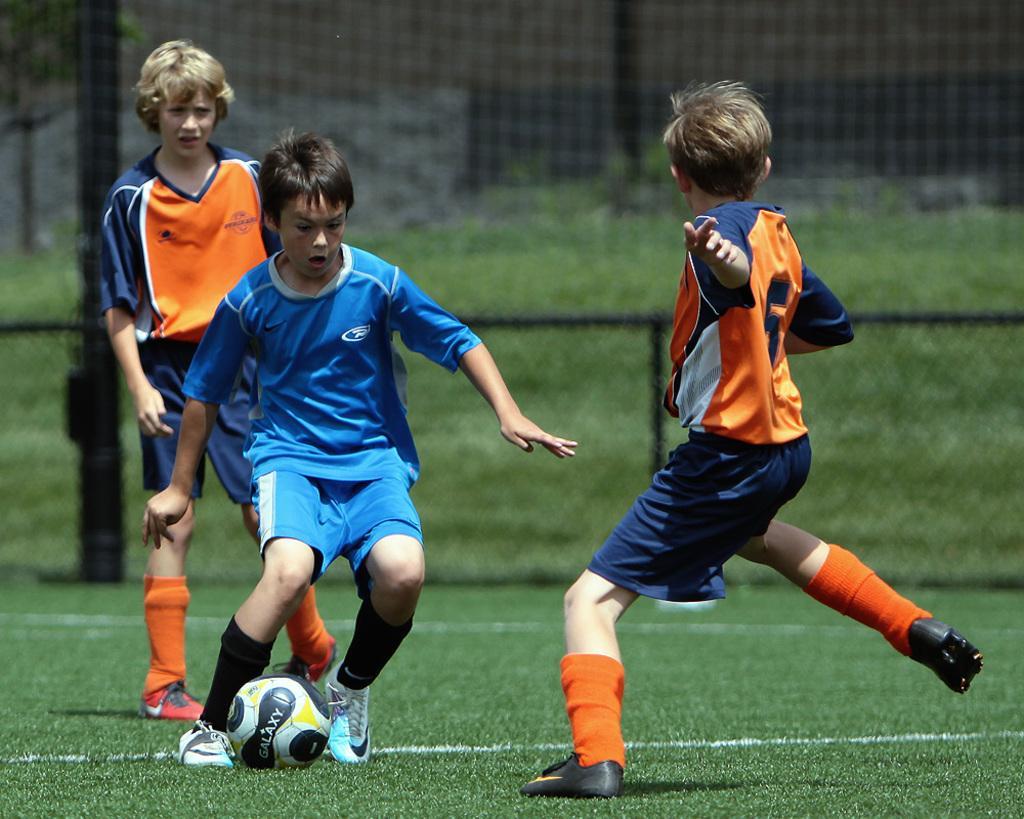In one or two sentences, can you explain what this image depicts? In this image we can see children running on the ground. In addition to this we can see sportsnet, fences, bushes and a ball on the ground. 